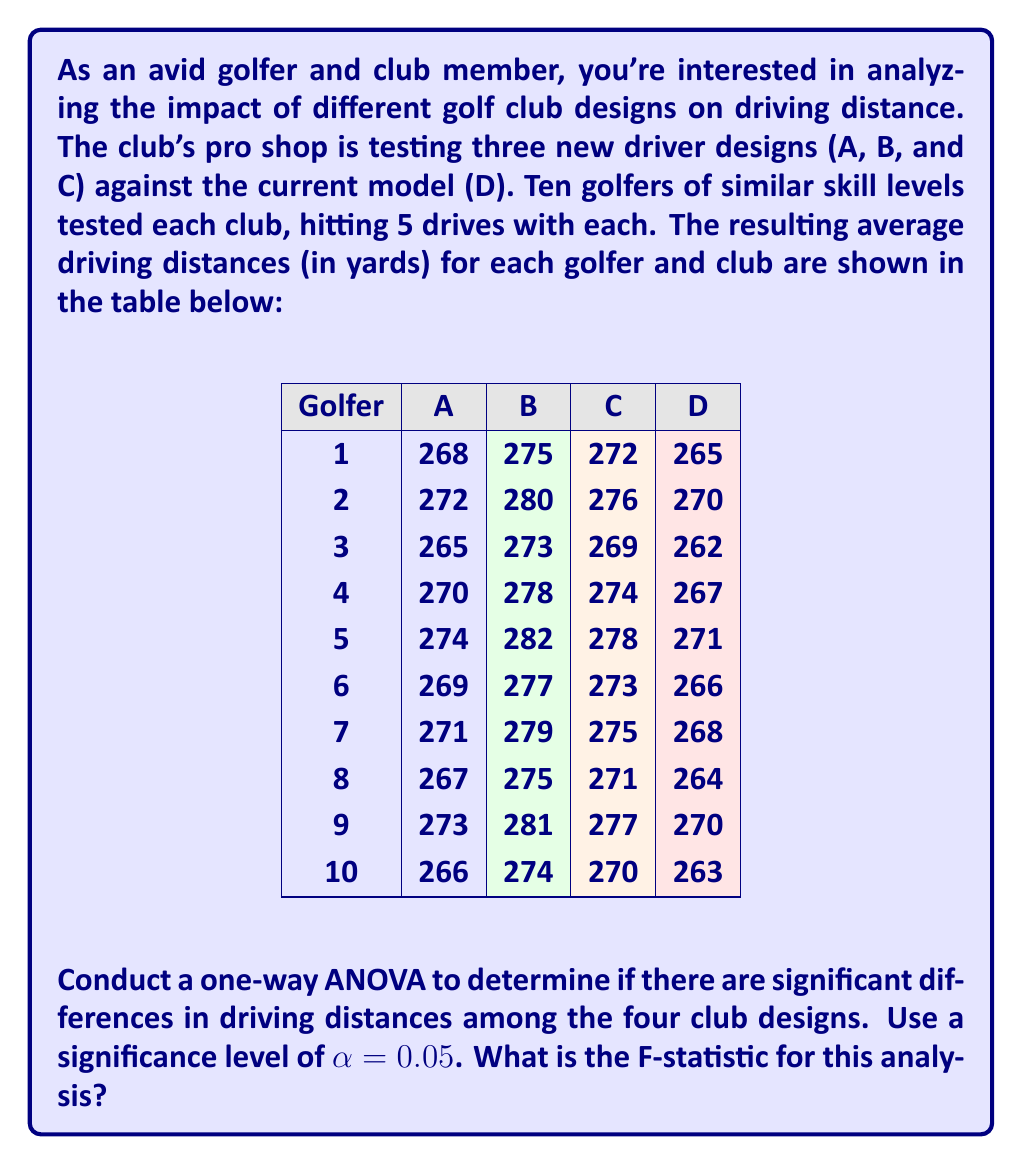Give your solution to this math problem. To conduct a one-way ANOVA, we'll follow these steps:

1) Calculate the sum of squares:
   a) Total sum of squares (SST)
   b) Between-group sum of squares (SSB)
   c) Within-group sum of squares (SSW)

2) Calculate degrees of freedom:
   a) Total (dfT)
   b) Between-group (dfB)
   c) Within-group (dfW)

3) Calculate mean squares:
   a) Between-group (MSB)
   b) Within-group (MSW)

4) Calculate the F-statistic

Step 1: Calculate sum of squares

a) SST = $\sum_{i=1}^{n} (x_i - \bar{x})^2$, where $\bar{x}$ is the grand mean
   Grand mean = 272.175
   SST = 3,986.975

b) SSB = $\sum_{j=1}^{k} n_j(\bar{x}_j - \bar{x})^2$, where $\bar{x}_j$ is the mean of each group
   Group means: A = 269.5, B = 277.4, C = 273.5, D = 266.6
   SSB = 3,461.675

c) SSW = SST - SSB = 3,986.975 - 3,461.675 = 525.3

Step 2: Calculate degrees of freedom

a) dfT = n - 1 = 40 - 1 = 39
b) dfB = k - 1 = 4 - 1 = 3
c) dfW = dfT - dfB = 39 - 3 = 36

Step 3: Calculate mean squares

a) MSB = SSB / dfB = 3,461.675 / 3 = 1,153.8917
b) MSW = SSW / dfW = 525.3 / 36 = 14.5917

Step 4: Calculate the F-statistic

F = MSB / MSW = 1,153.8917 / 14.5917 ≈ 79.08
Answer: 79.08 